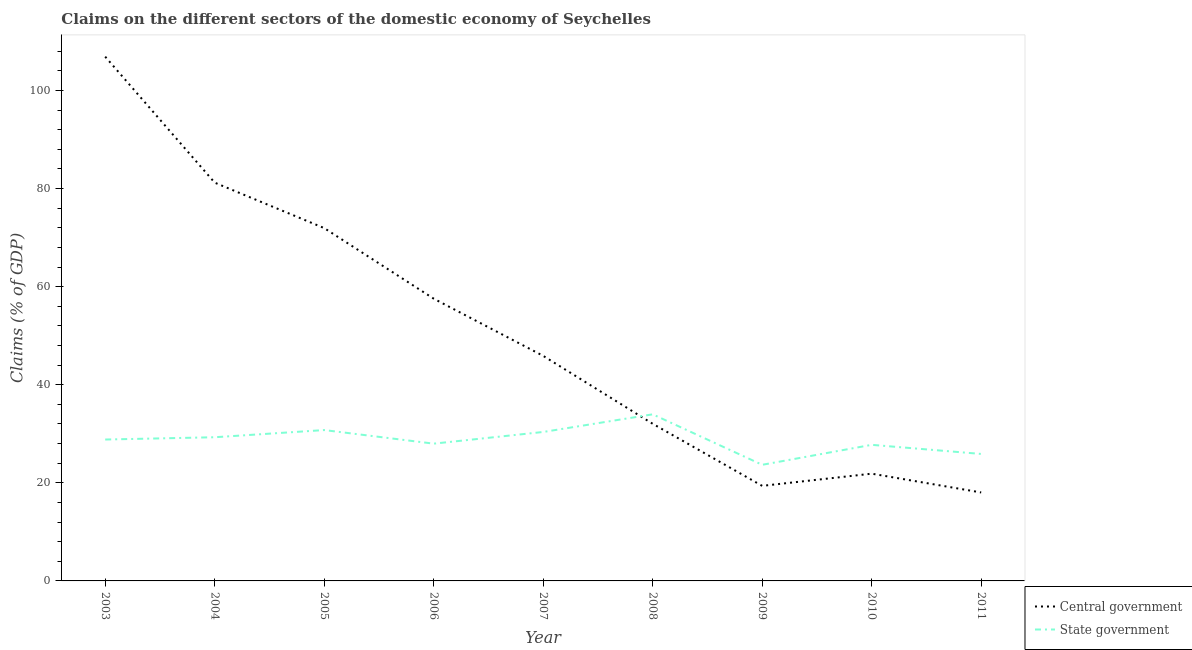Does the line corresponding to claims on central government intersect with the line corresponding to claims on state government?
Give a very brief answer. Yes. What is the claims on state government in 2010?
Your answer should be very brief. 27.75. Across all years, what is the maximum claims on central government?
Offer a very short reply. 106.88. Across all years, what is the minimum claims on central government?
Make the answer very short. 18.03. In which year was the claims on state government maximum?
Offer a terse response. 2008. In which year was the claims on state government minimum?
Offer a terse response. 2009. What is the total claims on central government in the graph?
Your answer should be very brief. 454.77. What is the difference between the claims on state government in 2008 and that in 2010?
Give a very brief answer. 6.22. What is the difference between the claims on state government in 2003 and the claims on central government in 2010?
Keep it short and to the point. 6.96. What is the average claims on central government per year?
Your response must be concise. 50.53. In the year 2011, what is the difference between the claims on central government and claims on state government?
Offer a very short reply. -7.85. What is the ratio of the claims on state government in 2004 to that in 2009?
Keep it short and to the point. 1.24. Is the difference between the claims on state government in 2007 and 2008 greater than the difference between the claims on central government in 2007 and 2008?
Ensure brevity in your answer.  No. What is the difference between the highest and the second highest claims on state government?
Keep it short and to the point. 3.21. What is the difference between the highest and the lowest claims on central government?
Offer a very short reply. 88.85. In how many years, is the claims on state government greater than the average claims on state government taken over all years?
Keep it short and to the point. 5. Is the sum of the claims on state government in 2004 and 2008 greater than the maximum claims on central government across all years?
Ensure brevity in your answer.  No. Is the claims on state government strictly greater than the claims on central government over the years?
Offer a terse response. No. Is the claims on state government strictly less than the claims on central government over the years?
Your answer should be compact. No. What is the difference between two consecutive major ticks on the Y-axis?
Ensure brevity in your answer.  20. Are the values on the major ticks of Y-axis written in scientific E-notation?
Your answer should be compact. No. Where does the legend appear in the graph?
Your answer should be very brief. Bottom right. How are the legend labels stacked?
Your answer should be very brief. Vertical. What is the title of the graph?
Provide a short and direct response. Claims on the different sectors of the domestic economy of Seychelles. What is the label or title of the X-axis?
Offer a terse response. Year. What is the label or title of the Y-axis?
Give a very brief answer. Claims (% of GDP). What is the Claims (% of GDP) in Central government in 2003?
Provide a short and direct response. 106.88. What is the Claims (% of GDP) of State government in 2003?
Your response must be concise. 28.83. What is the Claims (% of GDP) of Central government in 2004?
Keep it short and to the point. 81.2. What is the Claims (% of GDP) of State government in 2004?
Provide a short and direct response. 29.29. What is the Claims (% of GDP) in Central government in 2005?
Your answer should be very brief. 71.94. What is the Claims (% of GDP) of State government in 2005?
Keep it short and to the point. 30.76. What is the Claims (% of GDP) of Central government in 2006?
Your answer should be compact. 57.54. What is the Claims (% of GDP) of State government in 2006?
Your answer should be compact. 27.99. What is the Claims (% of GDP) in Central government in 2007?
Your answer should be compact. 45.88. What is the Claims (% of GDP) in State government in 2007?
Offer a terse response. 30.37. What is the Claims (% of GDP) in Central government in 2008?
Offer a terse response. 32.04. What is the Claims (% of GDP) in State government in 2008?
Your answer should be compact. 33.96. What is the Claims (% of GDP) in Central government in 2009?
Offer a very short reply. 19.38. What is the Claims (% of GDP) of State government in 2009?
Ensure brevity in your answer.  23.67. What is the Claims (% of GDP) of Central government in 2010?
Your answer should be very brief. 21.87. What is the Claims (% of GDP) in State government in 2010?
Your answer should be very brief. 27.75. What is the Claims (% of GDP) in Central government in 2011?
Provide a short and direct response. 18.03. What is the Claims (% of GDP) of State government in 2011?
Provide a succinct answer. 25.89. Across all years, what is the maximum Claims (% of GDP) of Central government?
Provide a succinct answer. 106.88. Across all years, what is the maximum Claims (% of GDP) of State government?
Make the answer very short. 33.96. Across all years, what is the minimum Claims (% of GDP) of Central government?
Keep it short and to the point. 18.03. Across all years, what is the minimum Claims (% of GDP) of State government?
Provide a succinct answer. 23.67. What is the total Claims (% of GDP) of Central government in the graph?
Your response must be concise. 454.77. What is the total Claims (% of GDP) of State government in the graph?
Give a very brief answer. 258.5. What is the difference between the Claims (% of GDP) in Central government in 2003 and that in 2004?
Your answer should be very brief. 25.68. What is the difference between the Claims (% of GDP) in State government in 2003 and that in 2004?
Ensure brevity in your answer.  -0.47. What is the difference between the Claims (% of GDP) in Central government in 2003 and that in 2005?
Provide a short and direct response. 34.95. What is the difference between the Claims (% of GDP) in State government in 2003 and that in 2005?
Your answer should be very brief. -1.93. What is the difference between the Claims (% of GDP) in Central government in 2003 and that in 2006?
Make the answer very short. 49.34. What is the difference between the Claims (% of GDP) of State government in 2003 and that in 2006?
Your answer should be compact. 0.84. What is the difference between the Claims (% of GDP) in Central government in 2003 and that in 2007?
Your answer should be very brief. 61. What is the difference between the Claims (% of GDP) of State government in 2003 and that in 2007?
Your response must be concise. -1.54. What is the difference between the Claims (% of GDP) of Central government in 2003 and that in 2008?
Your response must be concise. 74.84. What is the difference between the Claims (% of GDP) of State government in 2003 and that in 2008?
Make the answer very short. -5.14. What is the difference between the Claims (% of GDP) in Central government in 2003 and that in 2009?
Your answer should be compact. 87.5. What is the difference between the Claims (% of GDP) in State government in 2003 and that in 2009?
Provide a short and direct response. 5.15. What is the difference between the Claims (% of GDP) in Central government in 2003 and that in 2010?
Your answer should be very brief. 85.02. What is the difference between the Claims (% of GDP) of State government in 2003 and that in 2010?
Make the answer very short. 1.08. What is the difference between the Claims (% of GDP) in Central government in 2003 and that in 2011?
Provide a succinct answer. 88.85. What is the difference between the Claims (% of GDP) in State government in 2003 and that in 2011?
Give a very brief answer. 2.94. What is the difference between the Claims (% of GDP) of Central government in 2004 and that in 2005?
Your response must be concise. 9.26. What is the difference between the Claims (% of GDP) of State government in 2004 and that in 2005?
Offer a terse response. -1.46. What is the difference between the Claims (% of GDP) in Central government in 2004 and that in 2006?
Give a very brief answer. 23.65. What is the difference between the Claims (% of GDP) in State government in 2004 and that in 2006?
Offer a very short reply. 1.31. What is the difference between the Claims (% of GDP) of Central government in 2004 and that in 2007?
Your answer should be compact. 35.31. What is the difference between the Claims (% of GDP) of State government in 2004 and that in 2007?
Your response must be concise. -1.07. What is the difference between the Claims (% of GDP) in Central government in 2004 and that in 2008?
Provide a short and direct response. 49.16. What is the difference between the Claims (% of GDP) in State government in 2004 and that in 2008?
Give a very brief answer. -4.67. What is the difference between the Claims (% of GDP) of Central government in 2004 and that in 2009?
Give a very brief answer. 61.82. What is the difference between the Claims (% of GDP) of State government in 2004 and that in 2009?
Provide a short and direct response. 5.62. What is the difference between the Claims (% of GDP) of Central government in 2004 and that in 2010?
Make the answer very short. 59.33. What is the difference between the Claims (% of GDP) in State government in 2004 and that in 2010?
Ensure brevity in your answer.  1.55. What is the difference between the Claims (% of GDP) in Central government in 2004 and that in 2011?
Your response must be concise. 63.17. What is the difference between the Claims (% of GDP) of State government in 2004 and that in 2011?
Keep it short and to the point. 3.41. What is the difference between the Claims (% of GDP) in Central government in 2005 and that in 2006?
Offer a very short reply. 14.39. What is the difference between the Claims (% of GDP) of State government in 2005 and that in 2006?
Give a very brief answer. 2.77. What is the difference between the Claims (% of GDP) in Central government in 2005 and that in 2007?
Give a very brief answer. 26.05. What is the difference between the Claims (% of GDP) in State government in 2005 and that in 2007?
Your response must be concise. 0.39. What is the difference between the Claims (% of GDP) of Central government in 2005 and that in 2008?
Provide a succinct answer. 39.9. What is the difference between the Claims (% of GDP) of State government in 2005 and that in 2008?
Give a very brief answer. -3.21. What is the difference between the Claims (% of GDP) in Central government in 2005 and that in 2009?
Your response must be concise. 52.56. What is the difference between the Claims (% of GDP) of State government in 2005 and that in 2009?
Provide a succinct answer. 7.08. What is the difference between the Claims (% of GDP) in Central government in 2005 and that in 2010?
Provide a short and direct response. 50.07. What is the difference between the Claims (% of GDP) in State government in 2005 and that in 2010?
Offer a very short reply. 3.01. What is the difference between the Claims (% of GDP) in Central government in 2005 and that in 2011?
Keep it short and to the point. 53.9. What is the difference between the Claims (% of GDP) of State government in 2005 and that in 2011?
Provide a short and direct response. 4.87. What is the difference between the Claims (% of GDP) in Central government in 2006 and that in 2007?
Provide a short and direct response. 11.66. What is the difference between the Claims (% of GDP) of State government in 2006 and that in 2007?
Provide a short and direct response. -2.38. What is the difference between the Claims (% of GDP) in Central government in 2006 and that in 2008?
Give a very brief answer. 25.51. What is the difference between the Claims (% of GDP) in State government in 2006 and that in 2008?
Keep it short and to the point. -5.98. What is the difference between the Claims (% of GDP) of Central government in 2006 and that in 2009?
Provide a succinct answer. 38.16. What is the difference between the Claims (% of GDP) of State government in 2006 and that in 2009?
Your response must be concise. 4.31. What is the difference between the Claims (% of GDP) of Central government in 2006 and that in 2010?
Offer a terse response. 35.68. What is the difference between the Claims (% of GDP) in State government in 2006 and that in 2010?
Give a very brief answer. 0.24. What is the difference between the Claims (% of GDP) in Central government in 2006 and that in 2011?
Your answer should be compact. 39.51. What is the difference between the Claims (% of GDP) of State government in 2006 and that in 2011?
Your response must be concise. 2.1. What is the difference between the Claims (% of GDP) in Central government in 2007 and that in 2008?
Your answer should be compact. 13.85. What is the difference between the Claims (% of GDP) in State government in 2007 and that in 2008?
Ensure brevity in your answer.  -3.6. What is the difference between the Claims (% of GDP) of Central government in 2007 and that in 2009?
Give a very brief answer. 26.5. What is the difference between the Claims (% of GDP) in State government in 2007 and that in 2009?
Give a very brief answer. 6.69. What is the difference between the Claims (% of GDP) in Central government in 2007 and that in 2010?
Ensure brevity in your answer.  24.02. What is the difference between the Claims (% of GDP) in State government in 2007 and that in 2010?
Offer a terse response. 2.62. What is the difference between the Claims (% of GDP) of Central government in 2007 and that in 2011?
Offer a terse response. 27.85. What is the difference between the Claims (% of GDP) in State government in 2007 and that in 2011?
Keep it short and to the point. 4.48. What is the difference between the Claims (% of GDP) of Central government in 2008 and that in 2009?
Provide a short and direct response. 12.66. What is the difference between the Claims (% of GDP) of State government in 2008 and that in 2009?
Your response must be concise. 10.29. What is the difference between the Claims (% of GDP) of Central government in 2008 and that in 2010?
Provide a succinct answer. 10.17. What is the difference between the Claims (% of GDP) of State government in 2008 and that in 2010?
Provide a succinct answer. 6.22. What is the difference between the Claims (% of GDP) in Central government in 2008 and that in 2011?
Provide a succinct answer. 14. What is the difference between the Claims (% of GDP) of State government in 2008 and that in 2011?
Your response must be concise. 8.08. What is the difference between the Claims (% of GDP) in Central government in 2009 and that in 2010?
Give a very brief answer. -2.49. What is the difference between the Claims (% of GDP) of State government in 2009 and that in 2010?
Offer a very short reply. -4.07. What is the difference between the Claims (% of GDP) in Central government in 2009 and that in 2011?
Your answer should be very brief. 1.35. What is the difference between the Claims (% of GDP) in State government in 2009 and that in 2011?
Make the answer very short. -2.21. What is the difference between the Claims (% of GDP) of Central government in 2010 and that in 2011?
Your response must be concise. 3.83. What is the difference between the Claims (% of GDP) of State government in 2010 and that in 2011?
Make the answer very short. 1.86. What is the difference between the Claims (% of GDP) of Central government in 2003 and the Claims (% of GDP) of State government in 2004?
Your response must be concise. 77.59. What is the difference between the Claims (% of GDP) of Central government in 2003 and the Claims (% of GDP) of State government in 2005?
Make the answer very short. 76.13. What is the difference between the Claims (% of GDP) in Central government in 2003 and the Claims (% of GDP) in State government in 2006?
Your answer should be compact. 78.9. What is the difference between the Claims (% of GDP) in Central government in 2003 and the Claims (% of GDP) in State government in 2007?
Your answer should be compact. 76.52. What is the difference between the Claims (% of GDP) in Central government in 2003 and the Claims (% of GDP) in State government in 2008?
Give a very brief answer. 72.92. What is the difference between the Claims (% of GDP) in Central government in 2003 and the Claims (% of GDP) in State government in 2009?
Offer a terse response. 83.21. What is the difference between the Claims (% of GDP) in Central government in 2003 and the Claims (% of GDP) in State government in 2010?
Keep it short and to the point. 79.14. What is the difference between the Claims (% of GDP) in Central government in 2003 and the Claims (% of GDP) in State government in 2011?
Your answer should be very brief. 81. What is the difference between the Claims (% of GDP) of Central government in 2004 and the Claims (% of GDP) of State government in 2005?
Give a very brief answer. 50.44. What is the difference between the Claims (% of GDP) of Central government in 2004 and the Claims (% of GDP) of State government in 2006?
Keep it short and to the point. 53.21. What is the difference between the Claims (% of GDP) of Central government in 2004 and the Claims (% of GDP) of State government in 2007?
Your response must be concise. 50.83. What is the difference between the Claims (% of GDP) in Central government in 2004 and the Claims (% of GDP) in State government in 2008?
Give a very brief answer. 47.24. What is the difference between the Claims (% of GDP) in Central government in 2004 and the Claims (% of GDP) in State government in 2009?
Keep it short and to the point. 57.53. What is the difference between the Claims (% of GDP) of Central government in 2004 and the Claims (% of GDP) of State government in 2010?
Make the answer very short. 53.45. What is the difference between the Claims (% of GDP) of Central government in 2004 and the Claims (% of GDP) of State government in 2011?
Ensure brevity in your answer.  55.31. What is the difference between the Claims (% of GDP) in Central government in 2005 and the Claims (% of GDP) in State government in 2006?
Offer a very short reply. 43.95. What is the difference between the Claims (% of GDP) in Central government in 2005 and the Claims (% of GDP) in State government in 2007?
Ensure brevity in your answer.  41.57. What is the difference between the Claims (% of GDP) in Central government in 2005 and the Claims (% of GDP) in State government in 2008?
Keep it short and to the point. 37.97. What is the difference between the Claims (% of GDP) of Central government in 2005 and the Claims (% of GDP) of State government in 2009?
Your answer should be compact. 48.26. What is the difference between the Claims (% of GDP) of Central government in 2005 and the Claims (% of GDP) of State government in 2010?
Provide a short and direct response. 44.19. What is the difference between the Claims (% of GDP) of Central government in 2005 and the Claims (% of GDP) of State government in 2011?
Offer a terse response. 46.05. What is the difference between the Claims (% of GDP) of Central government in 2006 and the Claims (% of GDP) of State government in 2007?
Provide a succinct answer. 27.18. What is the difference between the Claims (% of GDP) in Central government in 2006 and the Claims (% of GDP) in State government in 2008?
Offer a very short reply. 23.58. What is the difference between the Claims (% of GDP) in Central government in 2006 and the Claims (% of GDP) in State government in 2009?
Keep it short and to the point. 33.87. What is the difference between the Claims (% of GDP) of Central government in 2006 and the Claims (% of GDP) of State government in 2010?
Keep it short and to the point. 29.8. What is the difference between the Claims (% of GDP) in Central government in 2006 and the Claims (% of GDP) in State government in 2011?
Give a very brief answer. 31.66. What is the difference between the Claims (% of GDP) of Central government in 2007 and the Claims (% of GDP) of State government in 2008?
Offer a terse response. 11.92. What is the difference between the Claims (% of GDP) of Central government in 2007 and the Claims (% of GDP) of State government in 2009?
Your response must be concise. 22.21. What is the difference between the Claims (% of GDP) of Central government in 2007 and the Claims (% of GDP) of State government in 2010?
Offer a terse response. 18.14. What is the difference between the Claims (% of GDP) of Central government in 2007 and the Claims (% of GDP) of State government in 2011?
Offer a terse response. 20. What is the difference between the Claims (% of GDP) of Central government in 2008 and the Claims (% of GDP) of State government in 2009?
Ensure brevity in your answer.  8.37. What is the difference between the Claims (% of GDP) of Central government in 2008 and the Claims (% of GDP) of State government in 2010?
Give a very brief answer. 4.29. What is the difference between the Claims (% of GDP) of Central government in 2008 and the Claims (% of GDP) of State government in 2011?
Give a very brief answer. 6.15. What is the difference between the Claims (% of GDP) of Central government in 2009 and the Claims (% of GDP) of State government in 2010?
Give a very brief answer. -8.37. What is the difference between the Claims (% of GDP) of Central government in 2009 and the Claims (% of GDP) of State government in 2011?
Make the answer very short. -6.51. What is the difference between the Claims (% of GDP) of Central government in 2010 and the Claims (% of GDP) of State government in 2011?
Your answer should be very brief. -4.02. What is the average Claims (% of GDP) of Central government per year?
Offer a very short reply. 50.53. What is the average Claims (% of GDP) in State government per year?
Keep it short and to the point. 28.72. In the year 2003, what is the difference between the Claims (% of GDP) of Central government and Claims (% of GDP) of State government?
Ensure brevity in your answer.  78.06. In the year 2004, what is the difference between the Claims (% of GDP) of Central government and Claims (% of GDP) of State government?
Keep it short and to the point. 51.91. In the year 2005, what is the difference between the Claims (% of GDP) of Central government and Claims (% of GDP) of State government?
Give a very brief answer. 41.18. In the year 2006, what is the difference between the Claims (% of GDP) in Central government and Claims (% of GDP) in State government?
Make the answer very short. 29.56. In the year 2007, what is the difference between the Claims (% of GDP) in Central government and Claims (% of GDP) in State government?
Provide a succinct answer. 15.52. In the year 2008, what is the difference between the Claims (% of GDP) in Central government and Claims (% of GDP) in State government?
Provide a succinct answer. -1.93. In the year 2009, what is the difference between the Claims (% of GDP) of Central government and Claims (% of GDP) of State government?
Keep it short and to the point. -4.29. In the year 2010, what is the difference between the Claims (% of GDP) of Central government and Claims (% of GDP) of State government?
Offer a very short reply. -5.88. In the year 2011, what is the difference between the Claims (% of GDP) in Central government and Claims (% of GDP) in State government?
Ensure brevity in your answer.  -7.85. What is the ratio of the Claims (% of GDP) in Central government in 2003 to that in 2004?
Offer a very short reply. 1.32. What is the ratio of the Claims (% of GDP) of State government in 2003 to that in 2004?
Offer a terse response. 0.98. What is the ratio of the Claims (% of GDP) of Central government in 2003 to that in 2005?
Your answer should be very brief. 1.49. What is the ratio of the Claims (% of GDP) in State government in 2003 to that in 2005?
Your answer should be compact. 0.94. What is the ratio of the Claims (% of GDP) of Central government in 2003 to that in 2006?
Offer a terse response. 1.86. What is the ratio of the Claims (% of GDP) of Central government in 2003 to that in 2007?
Make the answer very short. 2.33. What is the ratio of the Claims (% of GDP) in State government in 2003 to that in 2007?
Your answer should be compact. 0.95. What is the ratio of the Claims (% of GDP) of Central government in 2003 to that in 2008?
Offer a very short reply. 3.34. What is the ratio of the Claims (% of GDP) of State government in 2003 to that in 2008?
Give a very brief answer. 0.85. What is the ratio of the Claims (% of GDP) of Central government in 2003 to that in 2009?
Offer a terse response. 5.52. What is the ratio of the Claims (% of GDP) of State government in 2003 to that in 2009?
Offer a very short reply. 1.22. What is the ratio of the Claims (% of GDP) of Central government in 2003 to that in 2010?
Your answer should be very brief. 4.89. What is the ratio of the Claims (% of GDP) in State government in 2003 to that in 2010?
Provide a short and direct response. 1.04. What is the ratio of the Claims (% of GDP) in Central government in 2003 to that in 2011?
Offer a very short reply. 5.93. What is the ratio of the Claims (% of GDP) of State government in 2003 to that in 2011?
Keep it short and to the point. 1.11. What is the ratio of the Claims (% of GDP) of Central government in 2004 to that in 2005?
Make the answer very short. 1.13. What is the ratio of the Claims (% of GDP) of Central government in 2004 to that in 2006?
Offer a terse response. 1.41. What is the ratio of the Claims (% of GDP) of State government in 2004 to that in 2006?
Give a very brief answer. 1.05. What is the ratio of the Claims (% of GDP) in Central government in 2004 to that in 2007?
Provide a short and direct response. 1.77. What is the ratio of the Claims (% of GDP) of State government in 2004 to that in 2007?
Your response must be concise. 0.96. What is the ratio of the Claims (% of GDP) of Central government in 2004 to that in 2008?
Your response must be concise. 2.53. What is the ratio of the Claims (% of GDP) in State government in 2004 to that in 2008?
Make the answer very short. 0.86. What is the ratio of the Claims (% of GDP) of Central government in 2004 to that in 2009?
Provide a short and direct response. 4.19. What is the ratio of the Claims (% of GDP) of State government in 2004 to that in 2009?
Offer a very short reply. 1.24. What is the ratio of the Claims (% of GDP) of Central government in 2004 to that in 2010?
Keep it short and to the point. 3.71. What is the ratio of the Claims (% of GDP) in State government in 2004 to that in 2010?
Offer a terse response. 1.06. What is the ratio of the Claims (% of GDP) of Central government in 2004 to that in 2011?
Offer a terse response. 4.5. What is the ratio of the Claims (% of GDP) in State government in 2004 to that in 2011?
Ensure brevity in your answer.  1.13. What is the ratio of the Claims (% of GDP) in Central government in 2005 to that in 2006?
Offer a very short reply. 1.25. What is the ratio of the Claims (% of GDP) in State government in 2005 to that in 2006?
Your response must be concise. 1.1. What is the ratio of the Claims (% of GDP) of Central government in 2005 to that in 2007?
Provide a succinct answer. 1.57. What is the ratio of the Claims (% of GDP) of State government in 2005 to that in 2007?
Provide a short and direct response. 1.01. What is the ratio of the Claims (% of GDP) in Central government in 2005 to that in 2008?
Provide a short and direct response. 2.25. What is the ratio of the Claims (% of GDP) in State government in 2005 to that in 2008?
Ensure brevity in your answer.  0.91. What is the ratio of the Claims (% of GDP) of Central government in 2005 to that in 2009?
Ensure brevity in your answer.  3.71. What is the ratio of the Claims (% of GDP) in State government in 2005 to that in 2009?
Your answer should be very brief. 1.3. What is the ratio of the Claims (% of GDP) in Central government in 2005 to that in 2010?
Your response must be concise. 3.29. What is the ratio of the Claims (% of GDP) of State government in 2005 to that in 2010?
Give a very brief answer. 1.11. What is the ratio of the Claims (% of GDP) of Central government in 2005 to that in 2011?
Keep it short and to the point. 3.99. What is the ratio of the Claims (% of GDP) in State government in 2005 to that in 2011?
Keep it short and to the point. 1.19. What is the ratio of the Claims (% of GDP) in Central government in 2006 to that in 2007?
Provide a short and direct response. 1.25. What is the ratio of the Claims (% of GDP) in State government in 2006 to that in 2007?
Make the answer very short. 0.92. What is the ratio of the Claims (% of GDP) of Central government in 2006 to that in 2008?
Make the answer very short. 1.8. What is the ratio of the Claims (% of GDP) of State government in 2006 to that in 2008?
Your response must be concise. 0.82. What is the ratio of the Claims (% of GDP) of Central government in 2006 to that in 2009?
Provide a succinct answer. 2.97. What is the ratio of the Claims (% of GDP) of State government in 2006 to that in 2009?
Ensure brevity in your answer.  1.18. What is the ratio of the Claims (% of GDP) in Central government in 2006 to that in 2010?
Provide a short and direct response. 2.63. What is the ratio of the Claims (% of GDP) in State government in 2006 to that in 2010?
Your answer should be compact. 1.01. What is the ratio of the Claims (% of GDP) of Central government in 2006 to that in 2011?
Offer a very short reply. 3.19. What is the ratio of the Claims (% of GDP) of State government in 2006 to that in 2011?
Provide a short and direct response. 1.08. What is the ratio of the Claims (% of GDP) in Central government in 2007 to that in 2008?
Your answer should be very brief. 1.43. What is the ratio of the Claims (% of GDP) in State government in 2007 to that in 2008?
Offer a very short reply. 0.89. What is the ratio of the Claims (% of GDP) of Central government in 2007 to that in 2009?
Ensure brevity in your answer.  2.37. What is the ratio of the Claims (% of GDP) in State government in 2007 to that in 2009?
Keep it short and to the point. 1.28. What is the ratio of the Claims (% of GDP) in Central government in 2007 to that in 2010?
Offer a very short reply. 2.1. What is the ratio of the Claims (% of GDP) of State government in 2007 to that in 2010?
Your answer should be very brief. 1.09. What is the ratio of the Claims (% of GDP) in Central government in 2007 to that in 2011?
Offer a very short reply. 2.54. What is the ratio of the Claims (% of GDP) in State government in 2007 to that in 2011?
Give a very brief answer. 1.17. What is the ratio of the Claims (% of GDP) in Central government in 2008 to that in 2009?
Your answer should be very brief. 1.65. What is the ratio of the Claims (% of GDP) in State government in 2008 to that in 2009?
Offer a terse response. 1.43. What is the ratio of the Claims (% of GDP) of Central government in 2008 to that in 2010?
Keep it short and to the point. 1.47. What is the ratio of the Claims (% of GDP) of State government in 2008 to that in 2010?
Provide a succinct answer. 1.22. What is the ratio of the Claims (% of GDP) of Central government in 2008 to that in 2011?
Provide a short and direct response. 1.78. What is the ratio of the Claims (% of GDP) of State government in 2008 to that in 2011?
Offer a terse response. 1.31. What is the ratio of the Claims (% of GDP) of Central government in 2009 to that in 2010?
Your answer should be very brief. 0.89. What is the ratio of the Claims (% of GDP) in State government in 2009 to that in 2010?
Your response must be concise. 0.85. What is the ratio of the Claims (% of GDP) in Central government in 2009 to that in 2011?
Provide a short and direct response. 1.07. What is the ratio of the Claims (% of GDP) of State government in 2009 to that in 2011?
Offer a very short reply. 0.91. What is the ratio of the Claims (% of GDP) in Central government in 2010 to that in 2011?
Provide a succinct answer. 1.21. What is the ratio of the Claims (% of GDP) of State government in 2010 to that in 2011?
Your answer should be compact. 1.07. What is the difference between the highest and the second highest Claims (% of GDP) in Central government?
Your answer should be very brief. 25.68. What is the difference between the highest and the second highest Claims (% of GDP) of State government?
Offer a very short reply. 3.21. What is the difference between the highest and the lowest Claims (% of GDP) in Central government?
Keep it short and to the point. 88.85. What is the difference between the highest and the lowest Claims (% of GDP) of State government?
Provide a succinct answer. 10.29. 